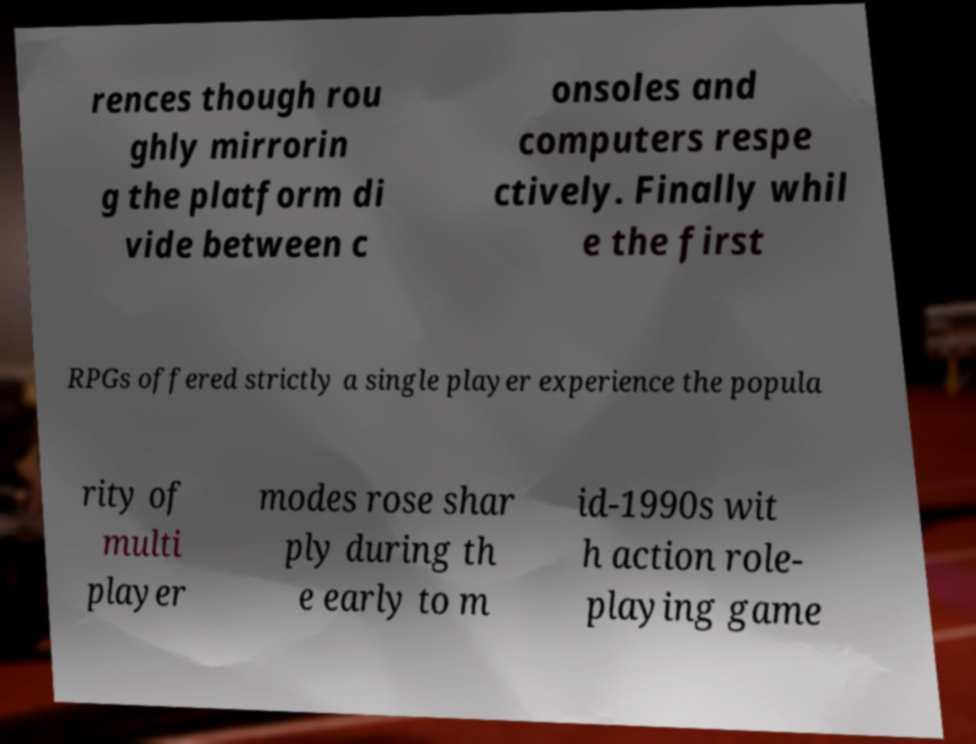There's text embedded in this image that I need extracted. Can you transcribe it verbatim? rences though rou ghly mirrorin g the platform di vide between c onsoles and computers respe ctively. Finally whil e the first RPGs offered strictly a single player experience the popula rity of multi player modes rose shar ply during th e early to m id-1990s wit h action role- playing game 